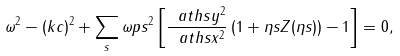Convert formula to latex. <formula><loc_0><loc_0><loc_500><loc_500>\omega ^ { 2 } - ( k c ) ^ { 2 } + \sum _ { s } \omega p s ^ { 2 } \left [ \frac { \ a t h s y ^ { 2 } } { \ a t h s x ^ { 2 } } \left ( 1 + \eta s Z ( \eta s ) \right ) - 1 \right ] = 0 ,</formula> 